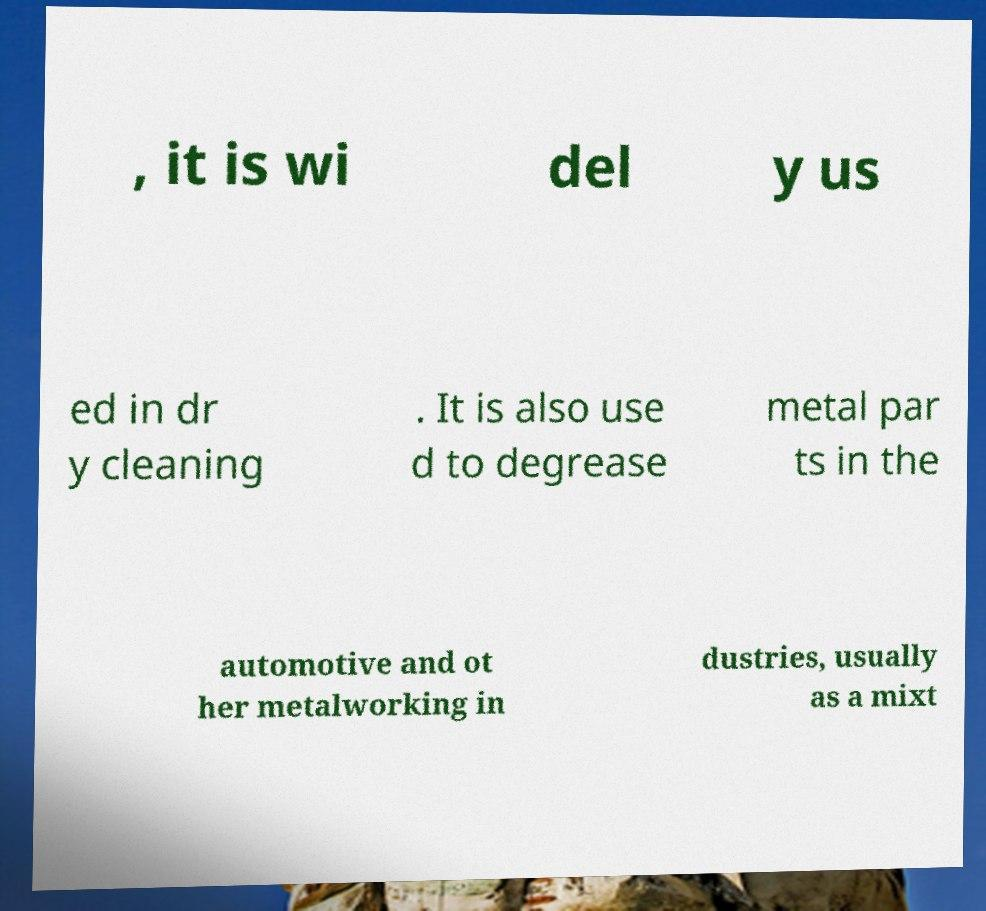I need the written content from this picture converted into text. Can you do that? , it is wi del y us ed in dr y cleaning . It is also use d to degrease metal par ts in the automotive and ot her metalworking in dustries, usually as a mixt 